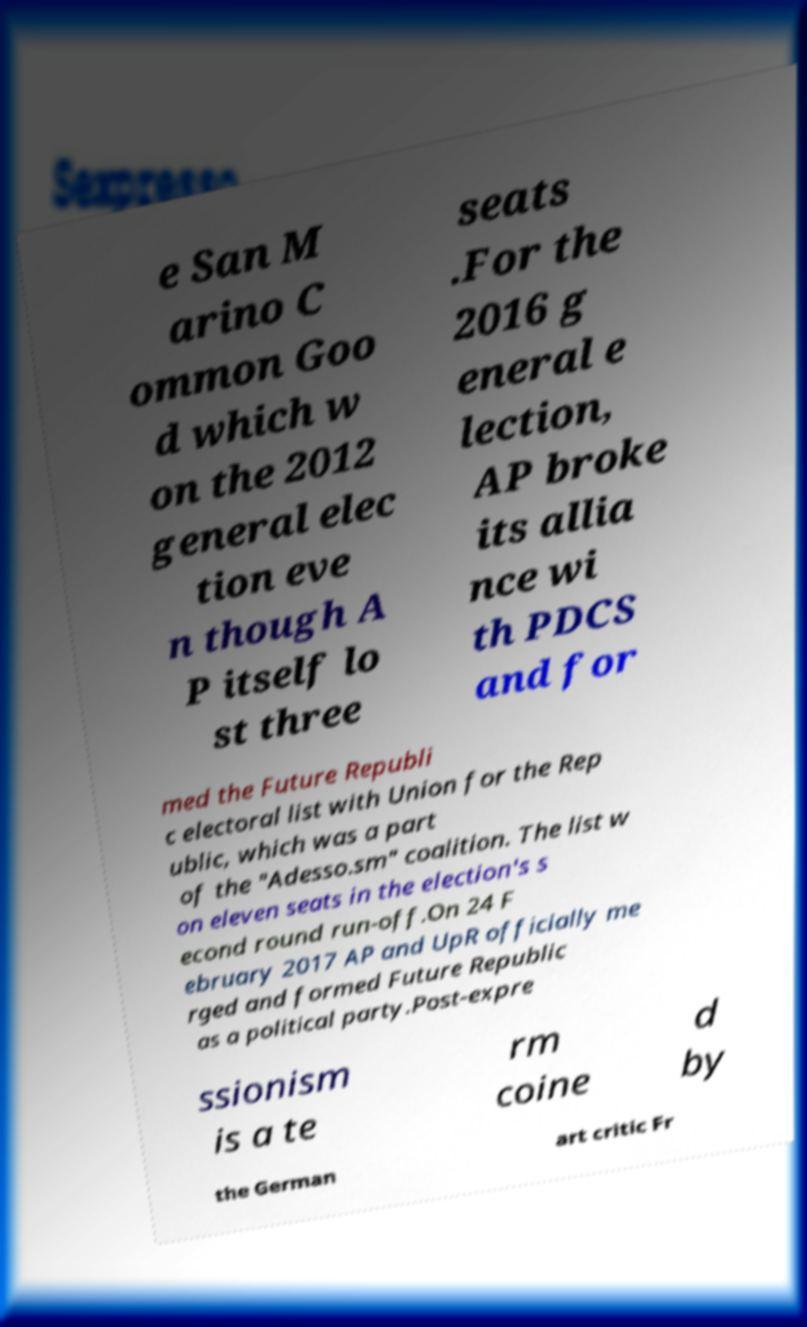Could you assist in decoding the text presented in this image and type it out clearly? e San M arino C ommon Goo d which w on the 2012 general elec tion eve n though A P itself lo st three seats .For the 2016 g eneral e lection, AP broke its allia nce wi th PDCS and for med the Future Republi c electoral list with Union for the Rep ublic, which was a part of the "Adesso.sm" coalition. The list w on eleven seats in the election's s econd round run-off.On 24 F ebruary 2017 AP and UpR officially me rged and formed Future Republic as a political party.Post-expre ssionism is a te rm coine d by the German art critic Fr 